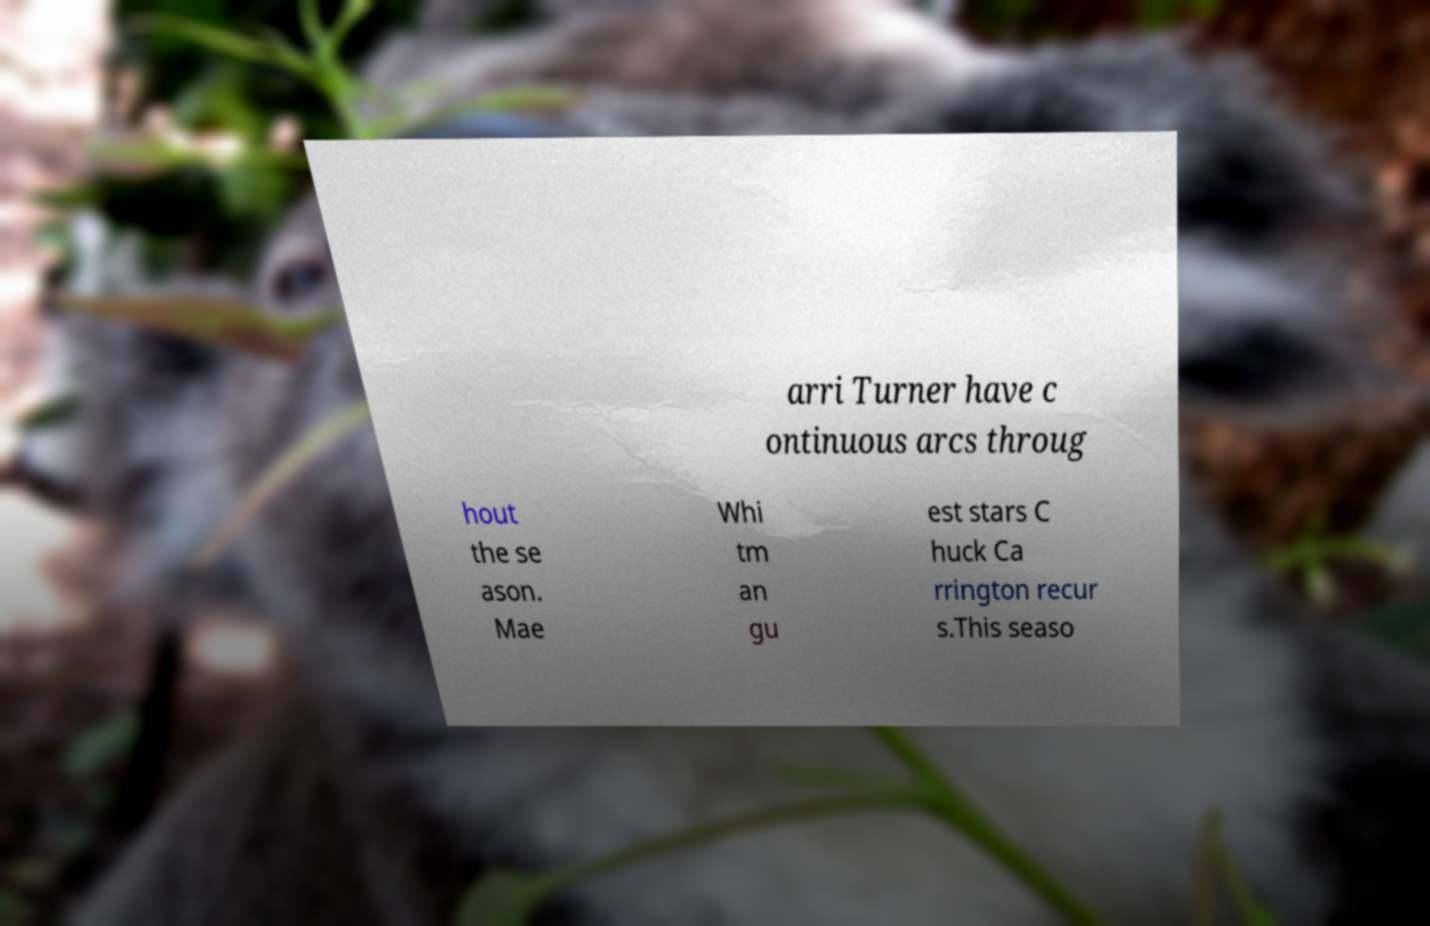Could you extract and type out the text from this image? arri Turner have c ontinuous arcs throug hout the se ason. Mae Whi tm an gu est stars C huck Ca rrington recur s.This seaso 